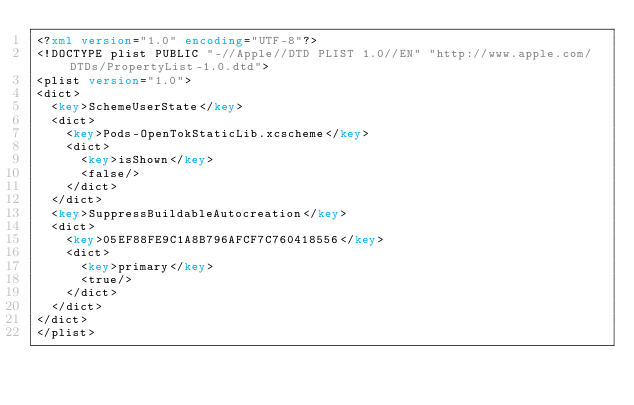Convert code to text. <code><loc_0><loc_0><loc_500><loc_500><_XML_><?xml version="1.0" encoding="UTF-8"?>
<!DOCTYPE plist PUBLIC "-//Apple//DTD PLIST 1.0//EN" "http://www.apple.com/DTDs/PropertyList-1.0.dtd">
<plist version="1.0">
<dict>
	<key>SchemeUserState</key>
	<dict>
		<key>Pods-OpenTokStaticLib.xcscheme</key>
		<dict>
			<key>isShown</key>
			<false/>
		</dict>
	</dict>
	<key>SuppressBuildableAutocreation</key>
	<dict>
		<key>05EF88FE9C1A8B796AFCF7C760418556</key>
		<dict>
			<key>primary</key>
			<true/>
		</dict>
	</dict>
</dict>
</plist>
</code> 